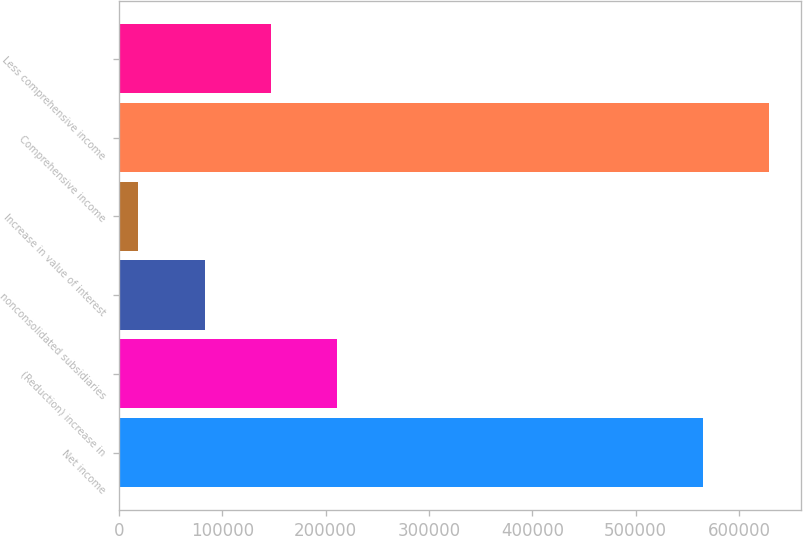<chart> <loc_0><loc_0><loc_500><loc_500><bar_chart><fcel>Net income<fcel>(Reduction) increase in<fcel>nonconsolidated subsidiaries<fcel>Increase in value of interest<fcel>Comprehensive income<fcel>Less comprehensive income<nl><fcel>564740<fcel>211257<fcel>82896.3<fcel>18716<fcel>628920<fcel>147077<nl></chart> 